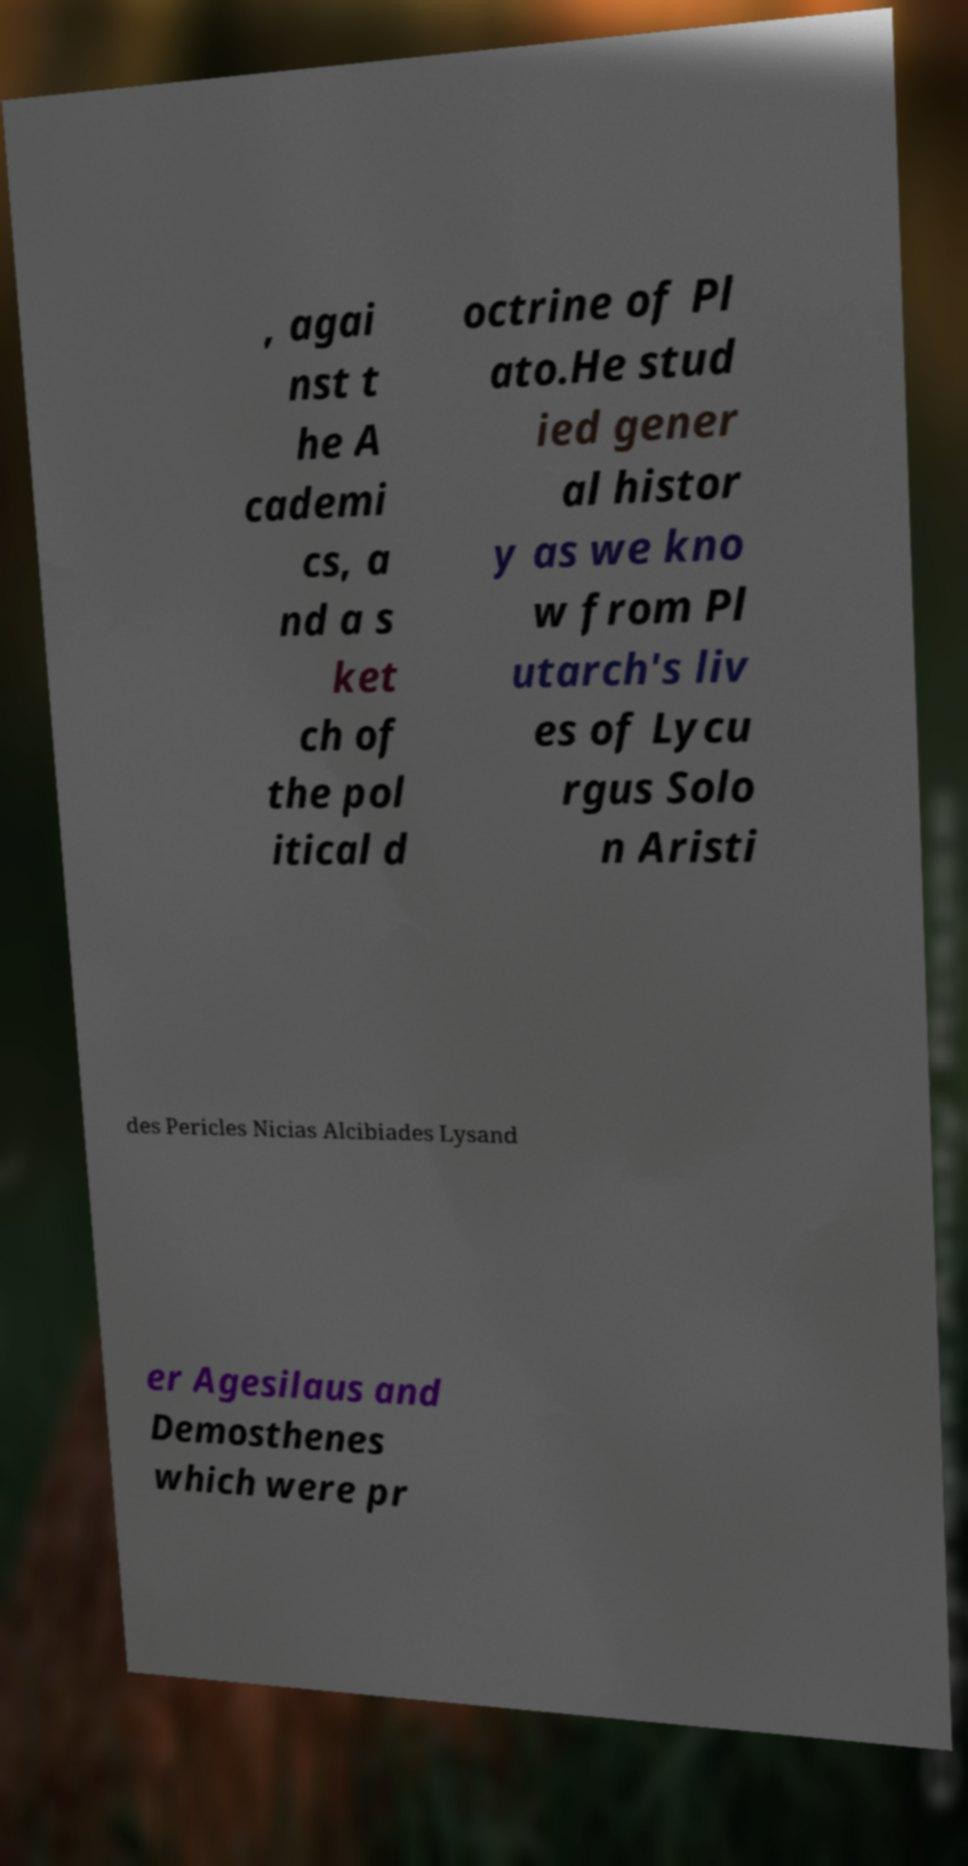Could you extract and type out the text from this image? , agai nst t he A cademi cs, a nd a s ket ch of the pol itical d octrine of Pl ato.He stud ied gener al histor y as we kno w from Pl utarch's liv es of Lycu rgus Solo n Aristi des Pericles Nicias Alcibiades Lysand er Agesilaus and Demosthenes which were pr 